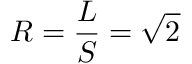<formula> <loc_0><loc_0><loc_500><loc_500>R = { \frac { L } { S } } = { \sqrt { 2 } }</formula> 